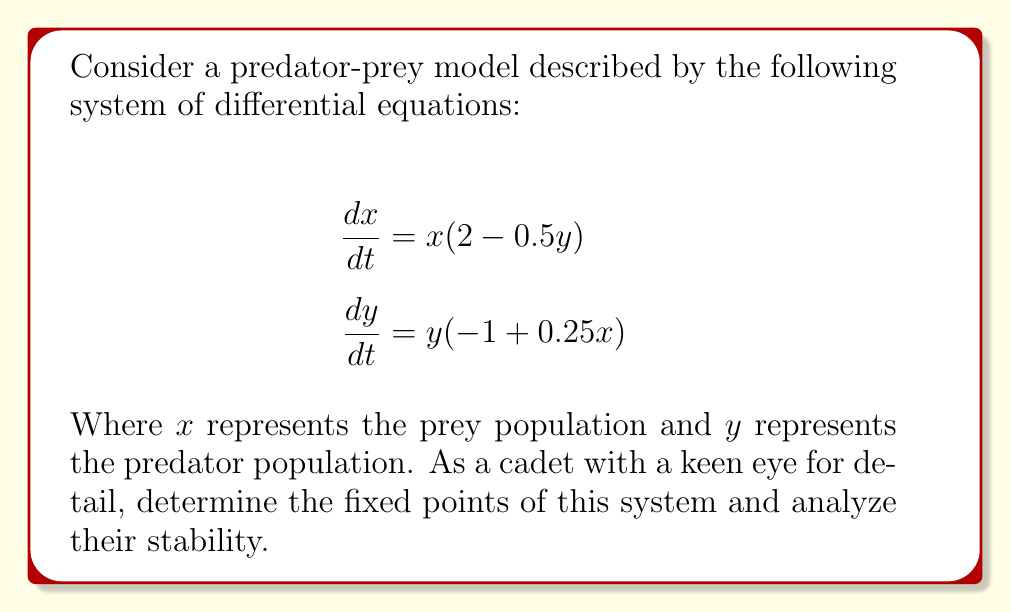Give your solution to this math problem. Step 1: Find the fixed points by setting both equations equal to zero.

$$\begin{align}
x(2 - 0.5y) &= 0 \\
y(-1 + 0.25x) &= 0
\end{align}$$

Step 2: Solve the equations.
From the first equation:
a) $x = 0$, or
b) $2 - 0.5y = 0 \implies y = 4$

From the second equation:
c) $y = 0$, or
d) $-1 + 0.25x = 0 \implies x = 4$

Step 3: Combine the solutions to find the fixed points.
Fixed point 1: $(0, 0)$
Fixed point 2: $(4, 4)$

Step 4: Analyze stability by finding the Jacobian matrix.

$$J = \begin{bmatrix}
\frac{\partial}{\partial x}(x(2-0.5y)) & \frac{\partial}{\partial y}(x(2-0.5y)) \\
\frac{\partial}{\partial x}(y(-1+0.25x)) & \frac{\partial}{\partial y}(y(-1+0.25x))
\end{bmatrix}$$

$$J = \begin{bmatrix}
2 - 0.5y & -0.5x \\
0.25y & -1 + 0.25x
\end{bmatrix}$$

Step 5: Evaluate the Jacobian at each fixed point.

For $(0, 0)$:
$$J_{(0,0)} = \begin{bmatrix}
2 & 0 \\
0 & -1
\end{bmatrix}$$

Eigenvalues: $\lambda_1 = 2$, $\lambda_2 = -1$
Since one eigenvalue is positive, this fixed point is unstable (saddle point).

For $(4, 4)$:
$$J_{(4,4)} = \begin{bmatrix}
0 & -2 \\
1 & 0
\end{bmatrix}$$

Eigenvalues: $\lambda = \pm i\sqrt{2}$
These are purely imaginary eigenvalues, indicating a center (neutrally stable).
Answer: Fixed points: $(0,0)$ (unstable saddle point) and $(4,4)$ (neutrally stable center). 